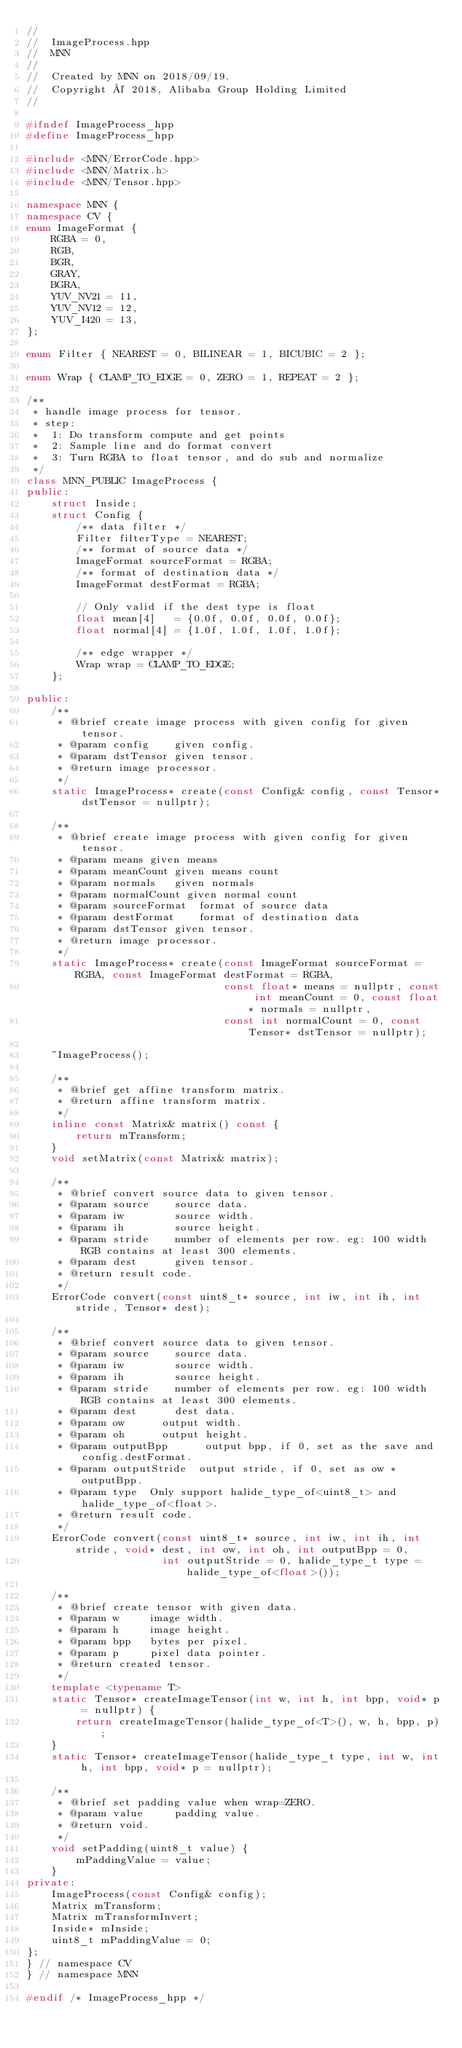<code> <loc_0><loc_0><loc_500><loc_500><_C++_>//
//  ImageProcess.hpp
//  MNN
//
//  Created by MNN on 2018/09/19.
//  Copyright © 2018, Alibaba Group Holding Limited
//

#ifndef ImageProcess_hpp
#define ImageProcess_hpp

#include <MNN/ErrorCode.hpp>
#include <MNN/Matrix.h>
#include <MNN/Tensor.hpp>

namespace MNN {
namespace CV {
enum ImageFormat {
    RGBA = 0,
    RGB,
    BGR,
    GRAY,
    BGRA,
    YUV_NV21 = 11,
    YUV_NV12 = 12,
    YUV_I420 = 13,
};

enum Filter { NEAREST = 0, BILINEAR = 1, BICUBIC = 2 };

enum Wrap { CLAMP_TO_EDGE = 0, ZERO = 1, REPEAT = 2 };

/**
 * handle image process for tensor.
 * step:
 *  1: Do transform compute and get points
 *  2: Sample line and do format convert
 *  3: Turn RGBA to float tensor, and do sub and normalize
 */
class MNN_PUBLIC ImageProcess {
public:
    struct Inside;
    struct Config {
        /** data filter */
        Filter filterType = NEAREST;
        /** format of source data */
        ImageFormat sourceFormat = RGBA;
        /** format of destination data */
        ImageFormat destFormat = RGBA;

        // Only valid if the dest type is float
        float mean[4]   = {0.0f, 0.0f, 0.0f, 0.0f};
        float normal[4] = {1.0f, 1.0f, 1.0f, 1.0f};

        /** edge wrapper */
        Wrap wrap = CLAMP_TO_EDGE;
    };

public:
    /**
     * @brief create image process with given config for given tensor.
     * @param config    given config.
     * @param dstTensor given tensor.
     * @return image processor.
     */
    static ImageProcess* create(const Config& config, const Tensor* dstTensor = nullptr);

    /**
     * @brief create image process with given config for given tensor.
     * @param means given means
     * @param meanCount given means count
     * @param normals   given normals
     * @param normalCount given normal count
     * @param sourceFormat  format of source data
     * @param destFormat    format of destination data
     * @param dstTensor given tensor.
     * @return image processor.
     */
    static ImageProcess* create(const ImageFormat sourceFormat = RGBA, const ImageFormat destFormat = RGBA,
                                const float* means = nullptr, const int meanCount = 0, const float* normals = nullptr,
                                const int normalCount = 0, const Tensor* dstTensor = nullptr);

    ~ImageProcess();

    /**
     * @brief get affine transform matrix.
     * @return affine transform matrix.
     */
    inline const Matrix& matrix() const {
        return mTransform;
    }
    void setMatrix(const Matrix& matrix);

    /**
     * @brief convert source data to given tensor.
     * @param source    source data.
     * @param iw        source width.
     * @param ih        source height.
     * @param stride    number of elements per row. eg: 100 width RGB contains at least 300 elements.
     * @param dest      given tensor.
     * @return result code.
     */
    ErrorCode convert(const uint8_t* source, int iw, int ih, int stride, Tensor* dest);

    /**
     * @brief convert source data to given tensor.
     * @param source    source data.
     * @param iw        source width.
     * @param ih        source height.
     * @param stride    number of elements per row. eg: 100 width RGB contains at least 300 elements.
     * @param dest      dest data.
     * @param ow      output width.
     * @param oh      output height.
     * @param outputBpp      output bpp, if 0, set as the save and config.destFormat.
     * @param outputStride  output stride, if 0, set as ow * outputBpp.
     * @param type  Only support halide_type_of<uint8_t> and halide_type_of<float>.
     * @return result code.
     */
    ErrorCode convert(const uint8_t* source, int iw, int ih, int stride, void* dest, int ow, int oh, int outputBpp = 0,
                      int outputStride = 0, halide_type_t type = halide_type_of<float>());

    /**
     * @brief create tensor with given data.
     * @param w     image width.
     * @param h     image height.
     * @param bpp   bytes per pixel.
     * @param p     pixel data pointer.
     * @return created tensor.
     */
    template <typename T>
    static Tensor* createImageTensor(int w, int h, int bpp, void* p = nullptr) {
        return createImageTensor(halide_type_of<T>(), w, h, bpp, p);
    }
    static Tensor* createImageTensor(halide_type_t type, int w, int h, int bpp, void* p = nullptr);

    /**
     * @brief set padding value when wrap=ZERO.
     * @param value     padding value.
     * @return void.
     */
    void setPadding(uint8_t value) {
        mPaddingValue = value;
    }
private:
    ImageProcess(const Config& config);
    Matrix mTransform;
    Matrix mTransformInvert;
    Inside* mInside;
    uint8_t mPaddingValue = 0;
};
} // namespace CV
} // namespace MNN

#endif /* ImageProcess_hpp */
</code> 